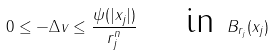<formula> <loc_0><loc_0><loc_500><loc_500>0 \leq - \Delta v \leq \frac { \psi ( | x _ { j } | ) } { r ^ { n } _ { j } } \quad \text { in } B _ { r _ { j } } ( x _ { j } )</formula> 